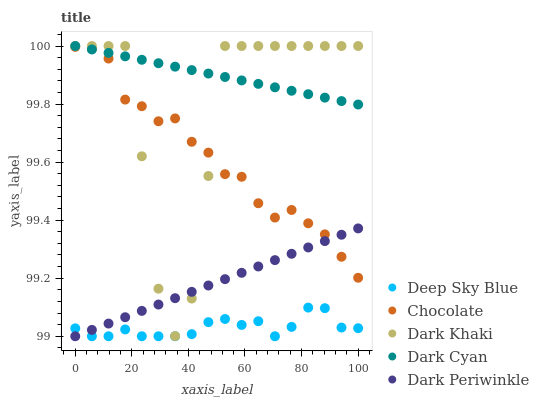Does Deep Sky Blue have the minimum area under the curve?
Answer yes or no. Yes. Does Dark Cyan have the maximum area under the curve?
Answer yes or no. Yes. Does Dark Periwinkle have the minimum area under the curve?
Answer yes or no. No. Does Dark Periwinkle have the maximum area under the curve?
Answer yes or no. No. Is Dark Periwinkle the smoothest?
Answer yes or no. Yes. Is Dark Khaki the roughest?
Answer yes or no. Yes. Is Dark Cyan the smoothest?
Answer yes or no. No. Is Dark Cyan the roughest?
Answer yes or no. No. Does Dark Periwinkle have the lowest value?
Answer yes or no. Yes. Does Dark Cyan have the lowest value?
Answer yes or no. No. Does Dark Cyan have the highest value?
Answer yes or no. Yes. Does Dark Periwinkle have the highest value?
Answer yes or no. No. Is Deep Sky Blue less than Dark Khaki?
Answer yes or no. Yes. Is Dark Khaki greater than Deep Sky Blue?
Answer yes or no. Yes. Does Dark Periwinkle intersect Deep Sky Blue?
Answer yes or no. Yes. Is Dark Periwinkle less than Deep Sky Blue?
Answer yes or no. No. Is Dark Periwinkle greater than Deep Sky Blue?
Answer yes or no. No. Does Deep Sky Blue intersect Dark Khaki?
Answer yes or no. No. 